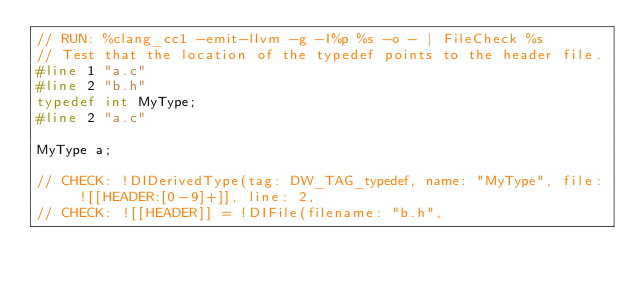<code> <loc_0><loc_0><loc_500><loc_500><_C_>// RUN: %clang_cc1 -emit-llvm -g -I%p %s -o - | FileCheck %s
// Test that the location of the typedef points to the header file.
#line 1 "a.c"
#line 2 "b.h"
typedef int MyType;
#line 2 "a.c"

MyType a;

// CHECK: !DIDerivedType(tag: DW_TAG_typedef, name: "MyType", file: ![[HEADER:[0-9]+]], line: 2,
// CHECK: ![[HEADER]] = !DIFile(filename: "b.h",
</code> 